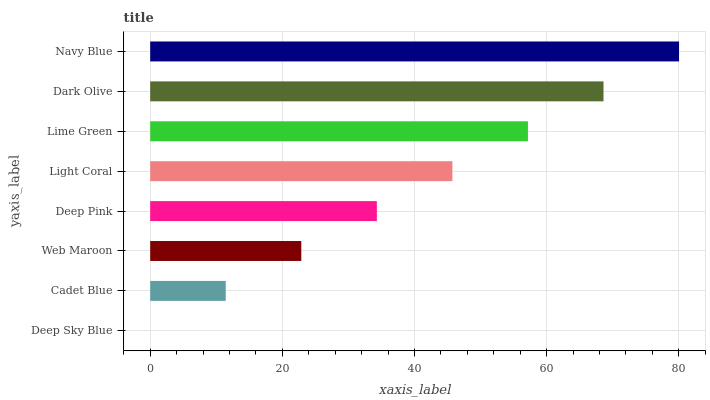Is Deep Sky Blue the minimum?
Answer yes or no. Yes. Is Navy Blue the maximum?
Answer yes or no. Yes. Is Cadet Blue the minimum?
Answer yes or no. No. Is Cadet Blue the maximum?
Answer yes or no. No. Is Cadet Blue greater than Deep Sky Blue?
Answer yes or no. Yes. Is Deep Sky Blue less than Cadet Blue?
Answer yes or no. Yes. Is Deep Sky Blue greater than Cadet Blue?
Answer yes or no. No. Is Cadet Blue less than Deep Sky Blue?
Answer yes or no. No. Is Light Coral the high median?
Answer yes or no. Yes. Is Deep Pink the low median?
Answer yes or no. Yes. Is Web Maroon the high median?
Answer yes or no. No. Is Web Maroon the low median?
Answer yes or no. No. 